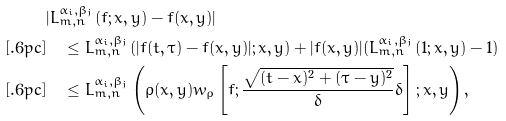Convert formula to latex. <formula><loc_0><loc_0><loc_500><loc_500>& | L _ { m , n } ^ { \alpha _ { i } , \beta _ { j } } ( f ; x , y ) - f ( x , y ) | \\ [ . 6 p c ] & \quad \leq L _ { m , n } ^ { \alpha _ { i } , \beta _ { j } } ( | f ( t , \tau ) - f ( x , y ) | ; x , y ) + | f ( x , y ) | ( L _ { m , n } ^ { \alpha _ { i } , \beta _ { j } } ( 1 ; x , y ) - 1 ) \\ [ . 6 p c ] & \quad \leq L _ { m , n } ^ { \alpha _ { i } , \beta _ { j } } \left ( \rho ( x , y ) w _ { \rho } \left [ f ; \frac { \sqrt { ( t - x ) ^ { 2 } + ( \tau - y ) ^ { 2 } } } { \delta } \delta \right ] ; x , y \right ) ,</formula> 